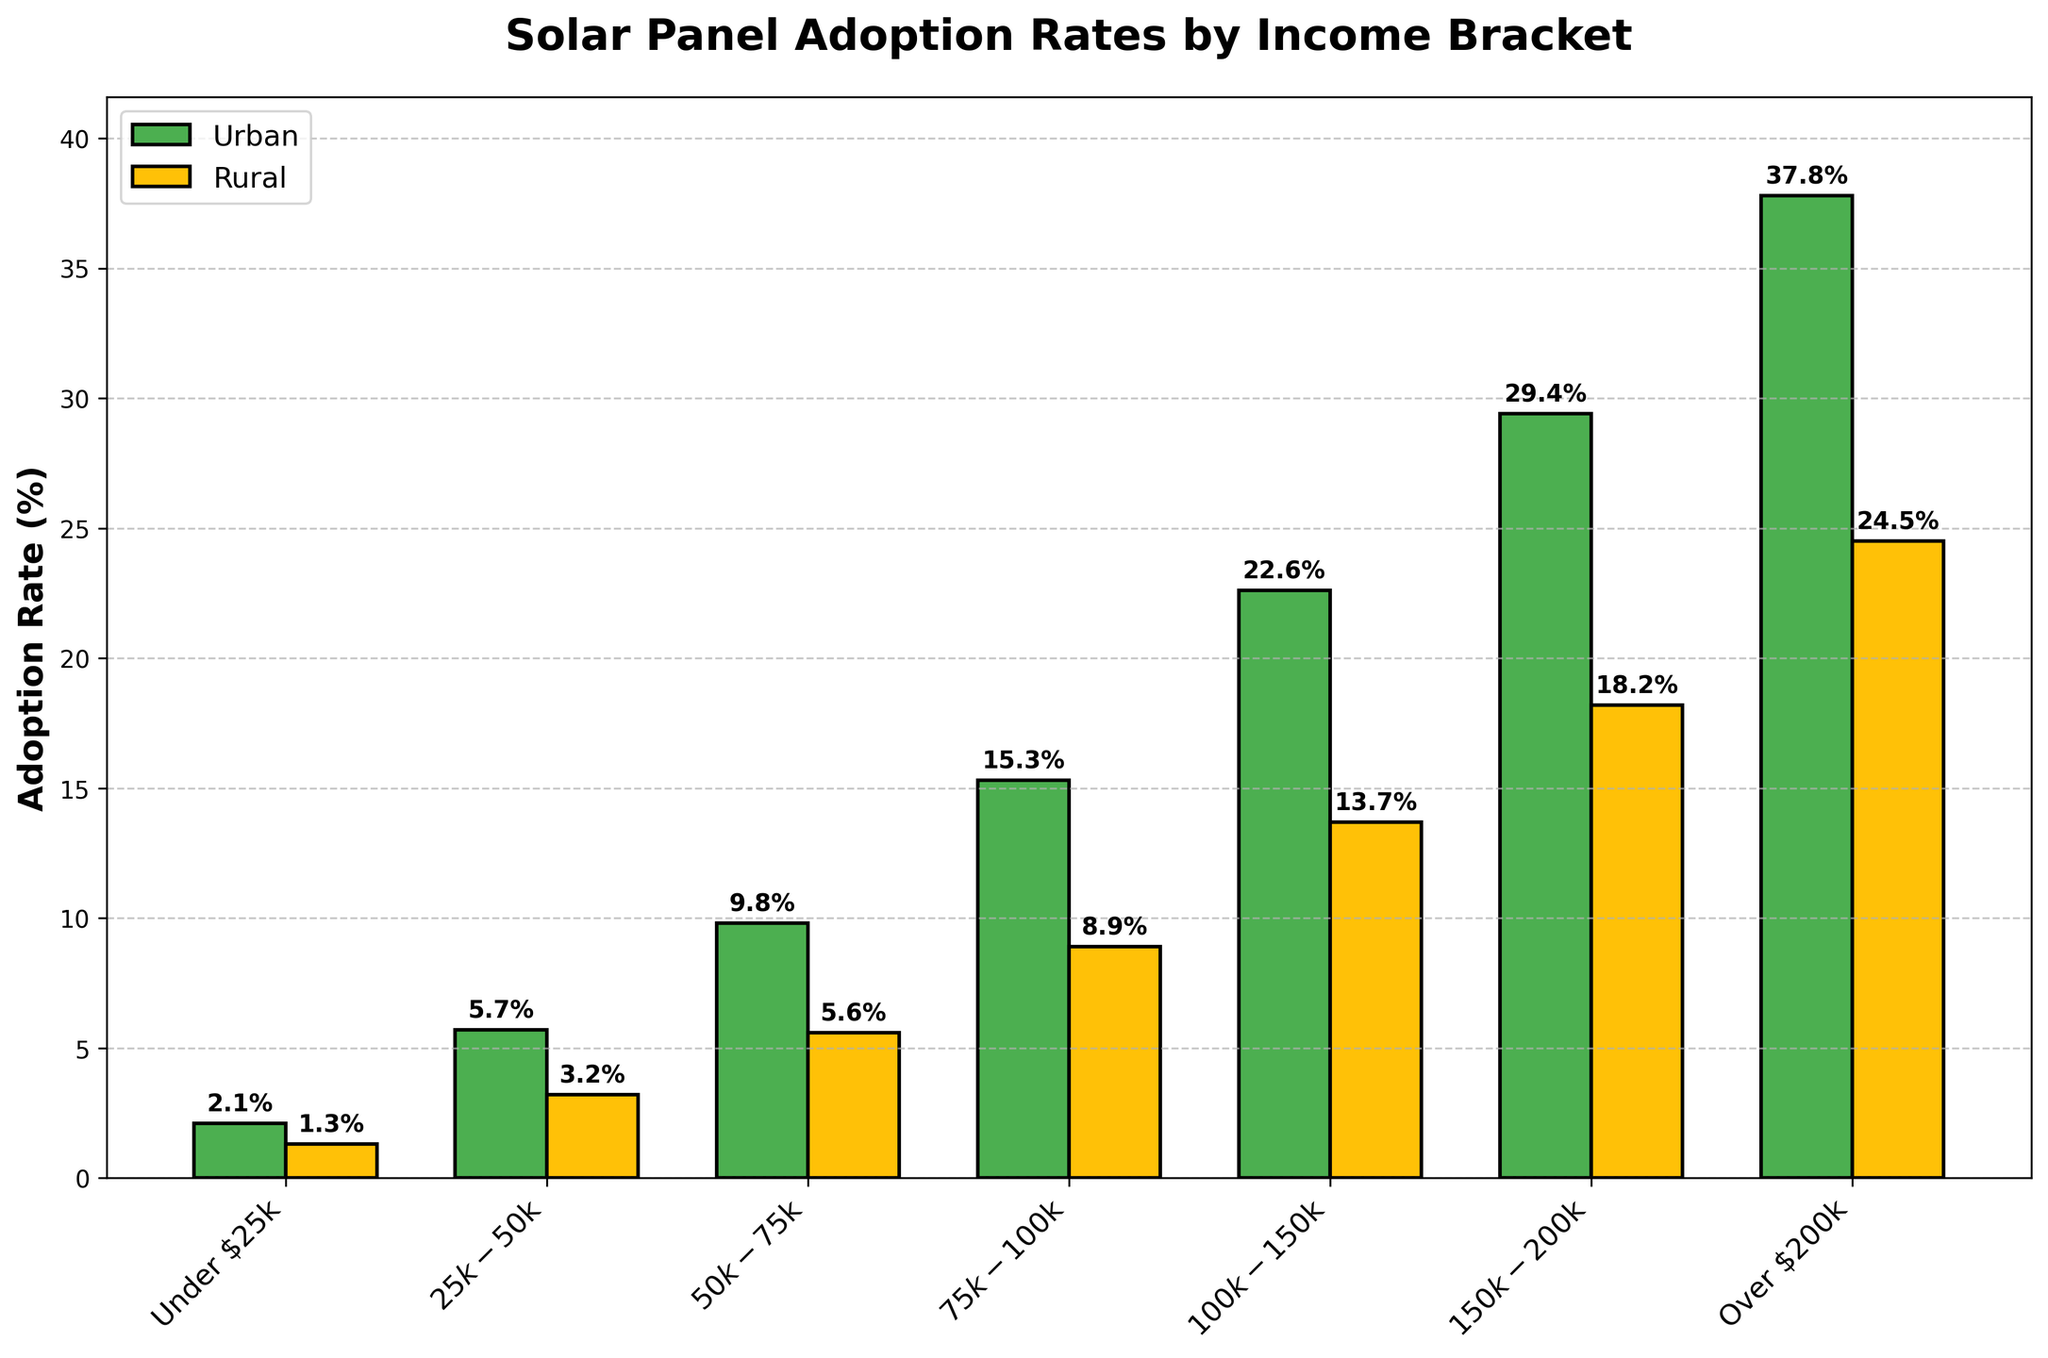Which income bracket has the highest urban adoption rate? The bar corresponding to the "Over $200k" income bracket is the tallest among the urban bars. Therefore, the "Over $200k" income bracket has the highest urban adoption rate.
Answer: Over $200k What's the difference in adoption rates between urban and rural areas in the $50k-$75k income bracket? The urban adoption rate for the $50k-$75k income bracket is 9.8%, and the rural adoption rate is 5.6%. The difference is found by subtracting 5.6 from 9.8, resulting in 4.2%.
Answer: 4.2% Is the adoption rate higher in rural areas or urban areas for the $75k-$100k income bracket? The bar representing urban adoption rate for the $75k-$100k income bracket is taller than the corresponding rural bar. Therefore, the adoption rate is higher in urban areas for this income bracket.
Answer: Urban areas Which income bracket shows the smallest adoption rate difference between urban and rural areas? By visually comparing the differences between the paired bars, the income bracket "$25k-$50k" has the smallest vertical difference between urban (5.7%) and rural (3.2%) bars. Calculate the difference: 5.7 - 3.2 = 2.5%.
Answer: $25k-$50k What is the average adoption rate across all income brackets in urban areas? To get the average adoption rate, sum all the urban adoption rates and divide by the number of income brackets. Sum: 2.1 + 5.7 + 9.8 + 15.3 + 22.6 + 29.4 + 37.8 = 122.7. The average is 122.7 / 7 ≈ 17.53%.
Answer: 17.53% How does the adoption rate for the "Under $25k" income bracket compare between urban and rural areas? The urban adoption rate for the "Under $25k" income bracket is 2.1%, while the rural rate is 1.3%. The urban rate is higher than the rural rate.
Answer: Urban rate is higher What percentage increase in adoption rate is seen when moving from the $100k-$150k to the $150k-$200k income bracket in rural areas? The rural adoption rate for the $100k-$150k bracket is 13.7%, and for the $150k-$200k bracket, it is 18.2%. The percentage increase is calculated as ((18.2 - 13.7) / 13.7) * 100 ≈ 32.85%.
Answer: 32.85% 